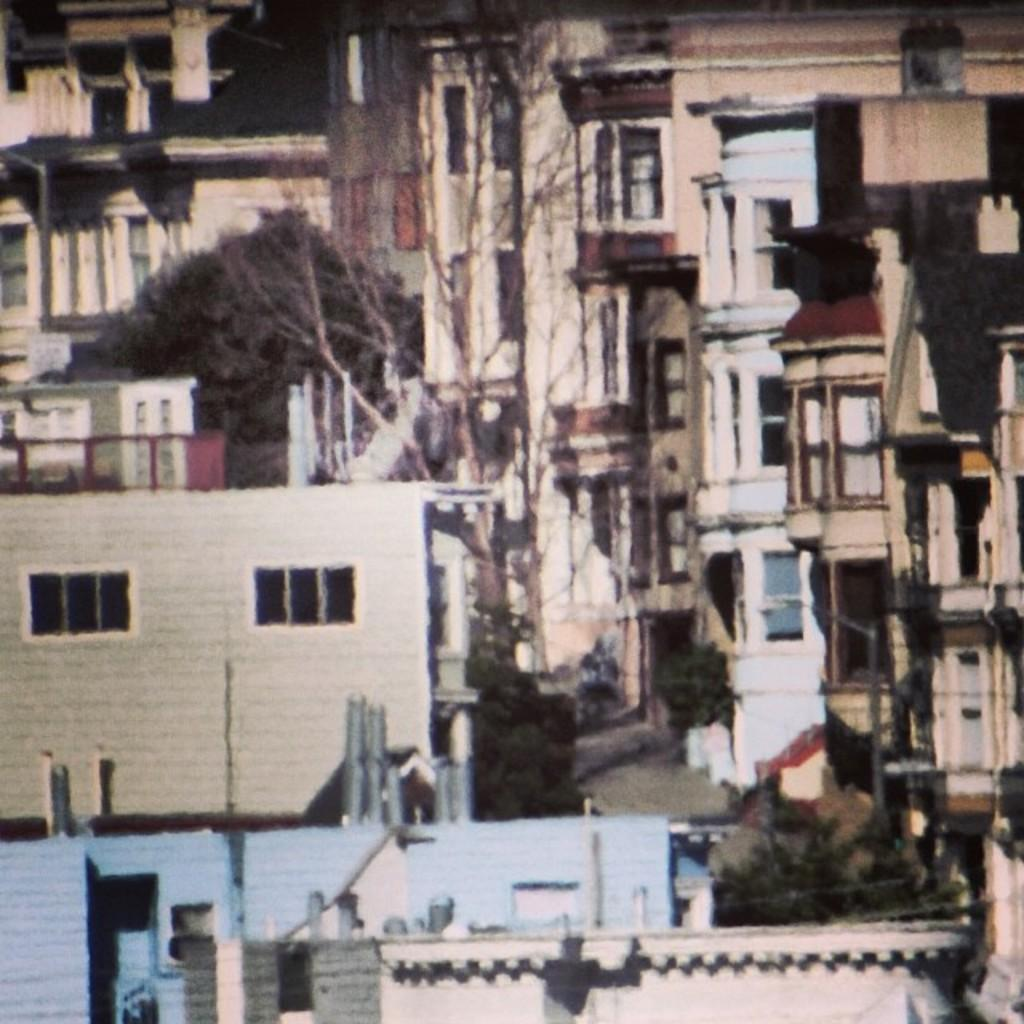What type of structures can be seen in the image? There are houses and buildings in the image. What type of natural elements can be seen in the image? There are trees in the image. What type of stocking can be seen hanging from the trees in the image? There is no stocking present in the image; it only features houses, buildings, and trees. What type of education is being taught in the image? There is no indication of any educational activity in the image. 